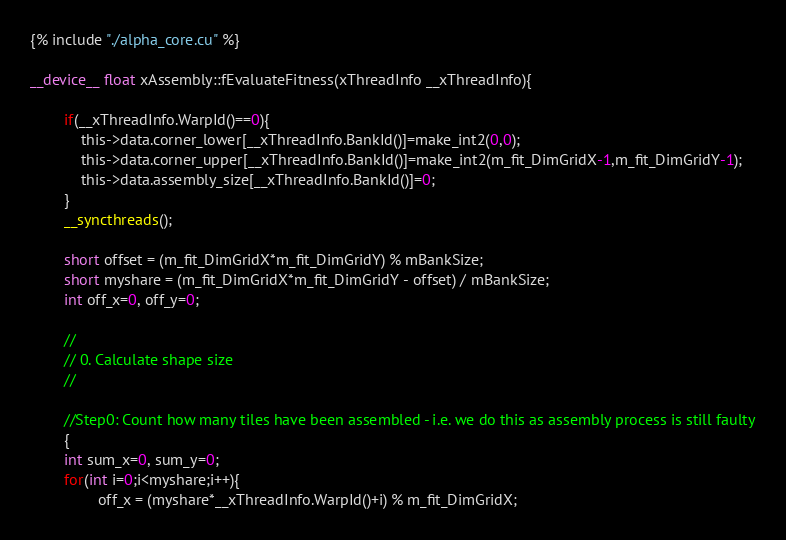<code> <loc_0><loc_0><loc_500><loc_500><_Cuda_>{% include "./alpha_core.cu" %}

__device__ float xAssembly::fEvaluateFitness(xThreadInfo __xThreadInfo){

        if(__xThreadInfo.WarpId()==0){
            this->data.corner_lower[__xThreadInfo.BankId()]=make_int2(0,0);
            this->data.corner_upper[__xThreadInfo.BankId()]=make_int2(m_fit_DimGridX-1,m_fit_DimGridY-1);
            this->data.assembly_size[__xThreadInfo.BankId()]=0; 
        } 
        __syncthreads();

        short offset = (m_fit_DimGridX*m_fit_DimGridY) % mBankSize;
        short myshare = (m_fit_DimGridX*m_fit_DimGridY - offset) / mBankSize;
        int off_x=0, off_y=0;

        //
        // 0. Calculate shape size
        //

        //Step0: Count how many tiles have been assembled - i.e. we do this as assembly process is still faulty
        {
        int sum_x=0, sum_y=0;
        for(int i=0;i<myshare;i++){
                off_x = (myshare*__xThreadInfo.WarpId()+i) % m_fit_DimGridX;</code> 